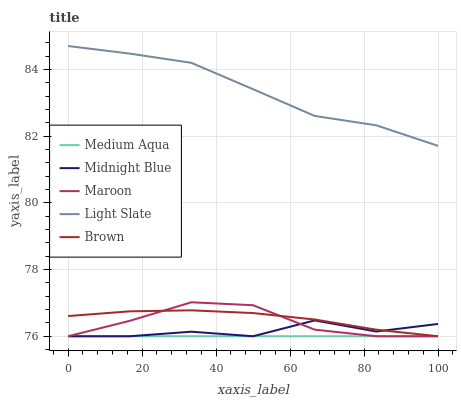Does Medium Aqua have the minimum area under the curve?
Answer yes or no. Yes. Does Light Slate have the maximum area under the curve?
Answer yes or no. Yes. Does Brown have the minimum area under the curve?
Answer yes or no. No. Does Brown have the maximum area under the curve?
Answer yes or no. No. Is Medium Aqua the smoothest?
Answer yes or no. Yes. Is Midnight Blue the roughest?
Answer yes or no. Yes. Is Brown the smoothest?
Answer yes or no. No. Is Brown the roughest?
Answer yes or no. No. Does Brown have the lowest value?
Answer yes or no. Yes. Does Light Slate have the highest value?
Answer yes or no. Yes. Does Brown have the highest value?
Answer yes or no. No. Is Brown less than Light Slate?
Answer yes or no. Yes. Is Light Slate greater than Midnight Blue?
Answer yes or no. Yes. Does Brown intersect Maroon?
Answer yes or no. Yes. Is Brown less than Maroon?
Answer yes or no. No. Is Brown greater than Maroon?
Answer yes or no. No. Does Brown intersect Light Slate?
Answer yes or no. No. 